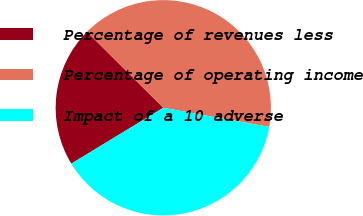Convert chart. <chart><loc_0><loc_0><loc_500><loc_500><pie_chart><fcel>Percentage of revenues less<fcel>Percentage of operating income<fcel>Impact of a 10 adverse<nl><fcel>21.15%<fcel>40.38%<fcel>38.46%<nl></chart> 